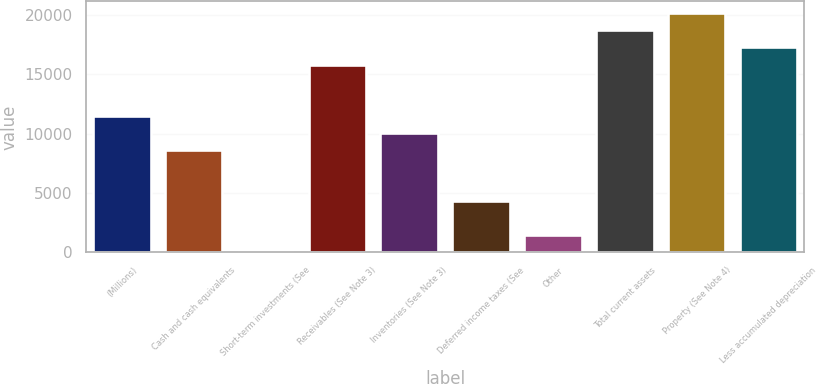Convert chart to OTSL. <chart><loc_0><loc_0><loc_500><loc_500><bar_chart><fcel>(Millions)<fcel>Cash and cash equivalents<fcel>Short-term investments (See<fcel>Receivables (See Note 3)<fcel>Inventories (See Note 3)<fcel>Deferred income taxes (See<fcel>Other<fcel>Total current assets<fcel>Property (See Note 4)<fcel>Less accumulated depreciation<nl><fcel>11510.6<fcel>8639.2<fcel>25<fcel>15817.7<fcel>10074.9<fcel>4332.1<fcel>1460.7<fcel>18689.1<fcel>20124.8<fcel>17253.4<nl></chart> 